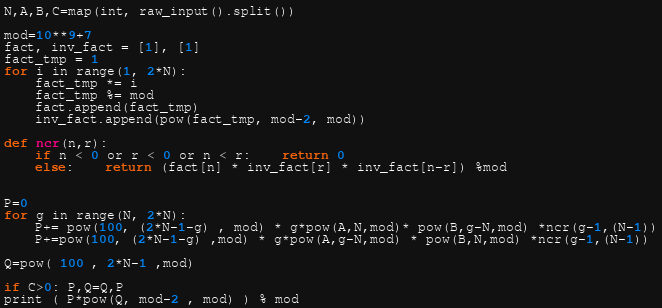<code> <loc_0><loc_0><loc_500><loc_500><_Python_>N,A,B,C=map(int, raw_input().split())

mod=10**9+7
fact, inv_fact = [1], [1]
fact_tmp = 1
for i in range(1, 2*N):
	fact_tmp *= i
	fact_tmp %= mod
	fact.append(fact_tmp)
	inv_fact.append(pow(fact_tmp, mod-2, mod))
 
def ncr(n,r):
	if n < 0 or r < 0 or n < r:	return 0
	else:	return (fact[n] * inv_fact[r] * inv_fact[n-r]) %mod


P=0
for g in range(N, 2*N):
	P+= pow(100, (2*N-1-g) , mod) * g*pow(A,N,mod)* pow(B,g-N,mod) *ncr(g-1,(N-1))
	P+=pow(100, (2*N-1-g) ,mod) * g*pow(A,g-N,mod) * pow(B,N,mod) *ncr(g-1,(N-1))

Q=pow( 100 , 2*N-1 ,mod)

if C>0: P,Q=Q,P
print ( P*pow(Q, mod-2 , mod) ) % mod</code> 